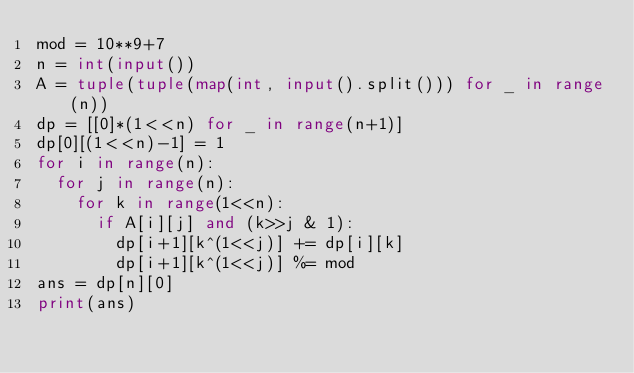<code> <loc_0><loc_0><loc_500><loc_500><_Python_>mod = 10**9+7
n = int(input())
A = tuple(tuple(map(int, input().split())) for _ in range(n))
dp = [[0]*(1<<n) for _ in range(n+1)]
dp[0][(1<<n)-1] = 1
for i in range(n):
  for j in range(n):
    for k in range(1<<n):
      if A[i][j] and (k>>j & 1):
        dp[i+1][k^(1<<j)] += dp[i][k]
        dp[i+1][k^(1<<j)] %= mod
ans = dp[n][0]
print(ans)</code> 